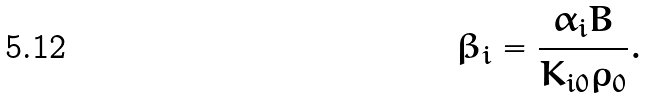Convert formula to latex. <formula><loc_0><loc_0><loc_500><loc_500>\beta _ { i } = \frac { \alpha _ { i } B } { K _ { i 0 } \rho _ { 0 } } .</formula> 